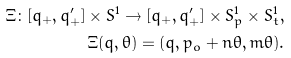Convert formula to latex. <formula><loc_0><loc_0><loc_500><loc_500>\Xi \colon [ q _ { + } , q ^ { \prime } _ { + } ] \times S ^ { 1 } \to [ q _ { + } , q ^ { \prime } _ { + } ] \times S ^ { 1 } _ { p } \times S ^ { 1 } _ { t } , \\ \Xi ( q , \theta ) = ( q , p _ { o } + n \theta , m \theta ) .</formula> 